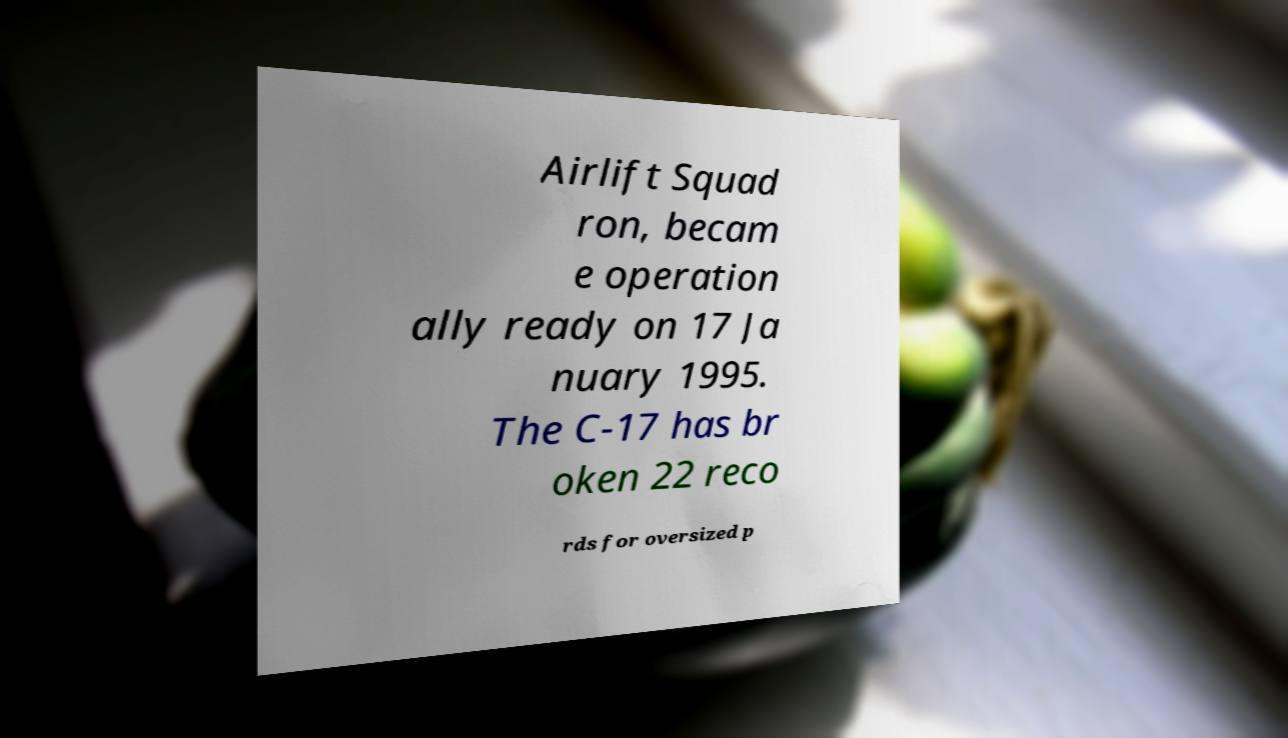Please read and relay the text visible in this image. What does it say? Airlift Squad ron, becam e operation ally ready on 17 Ja nuary 1995. The C-17 has br oken 22 reco rds for oversized p 